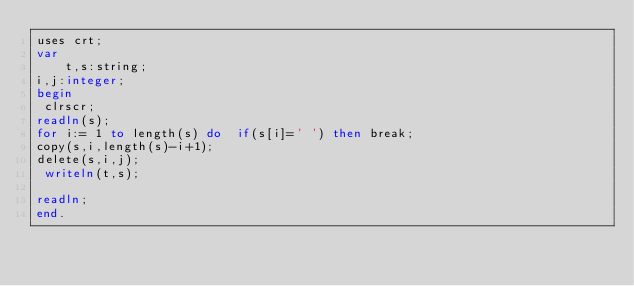<code> <loc_0><loc_0><loc_500><loc_500><_Pascal_>uses crt;
var
    t,s:string;
i,j:integer;
begin
 clrscr;
readln(s);
for i:= 1 to length(s) do  if(s[i]=' ') then break;
copy(s,i,length(s)-i+1);
delete(s,i,j);
 writeln(t,s);                                                                          
                                                   
readln;
end.</code> 